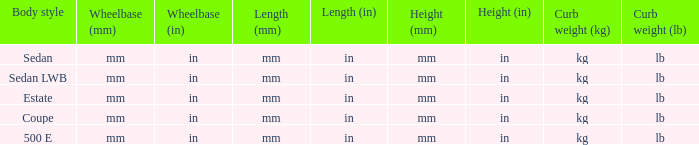What's the length of the model with Sedan body style? Mm (in). 